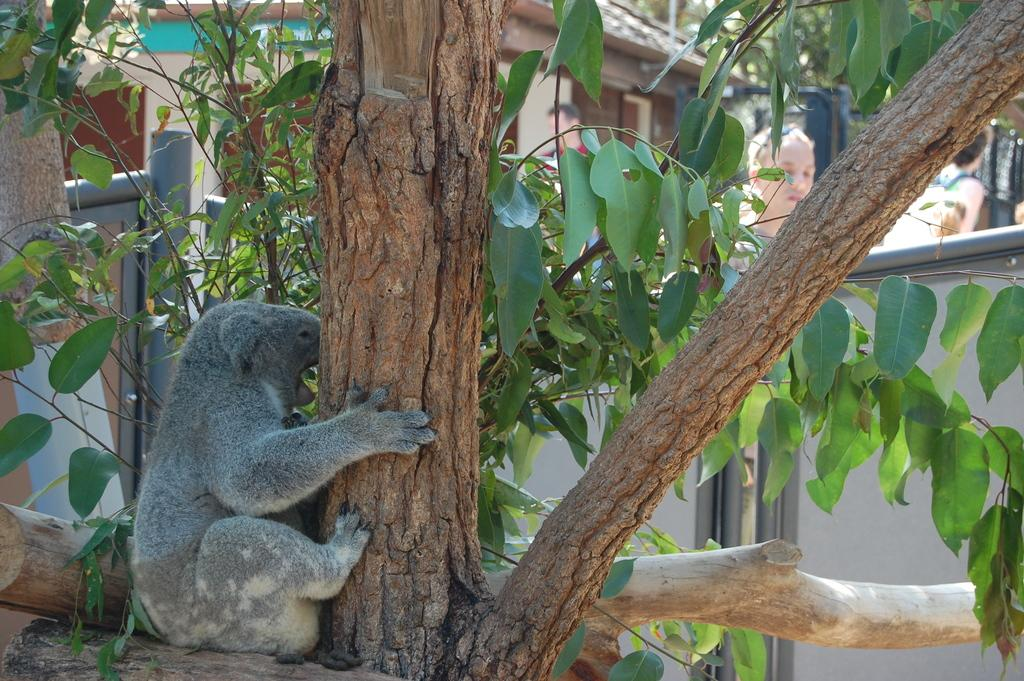What is the main object in the foreground of the image? There is a tree in the image. What animal is present near the tree? A Koala is present in front of the tree. What can be seen in the distance behind the tree? There is a house in the background of the image. Are there any people visible in the image? Yes, there are people visible in the background of the image. What type of berry is the Koala eating in the image? There is no berry present in the image, and the Koala is not shown eating anything. 